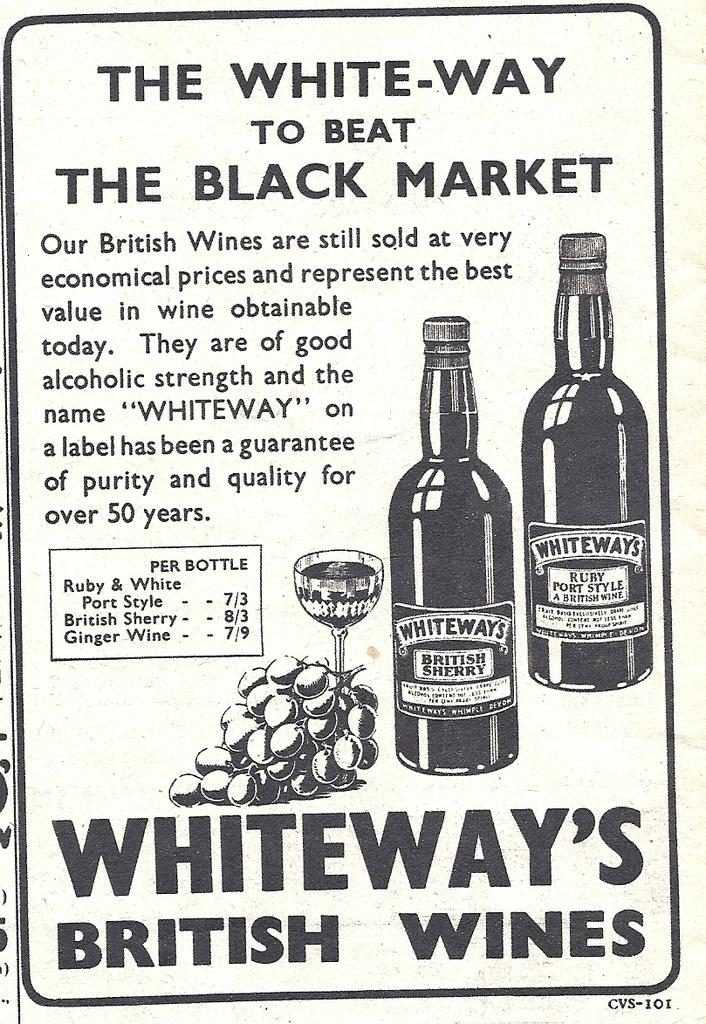<image>
Write a terse but informative summary of the picture. The "WHITEWAY" on a label has been a guarantee of purity and quality for over 50 years. 